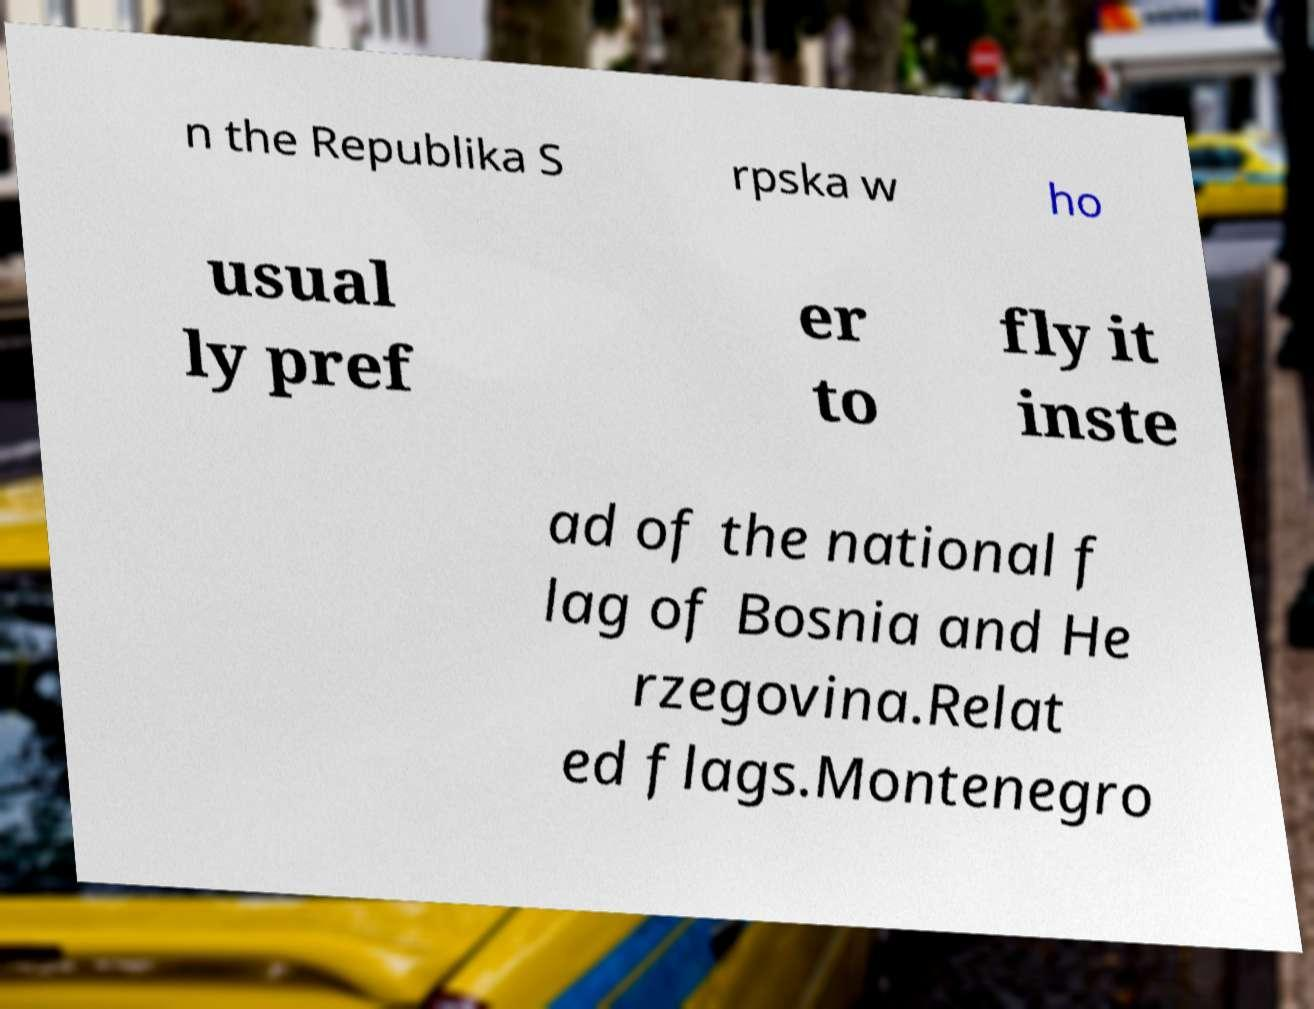Could you assist in decoding the text presented in this image and type it out clearly? n the Republika S rpska w ho usual ly pref er to fly it inste ad of the national f lag of Bosnia and He rzegovina.Relat ed flags.Montenegro 